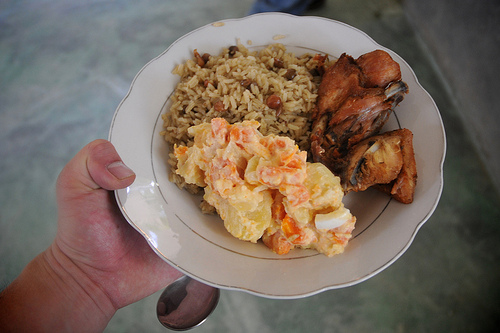<image>
Is the chicken to the left of the rice? No. The chicken is not to the left of the rice. From this viewpoint, they have a different horizontal relationship. 